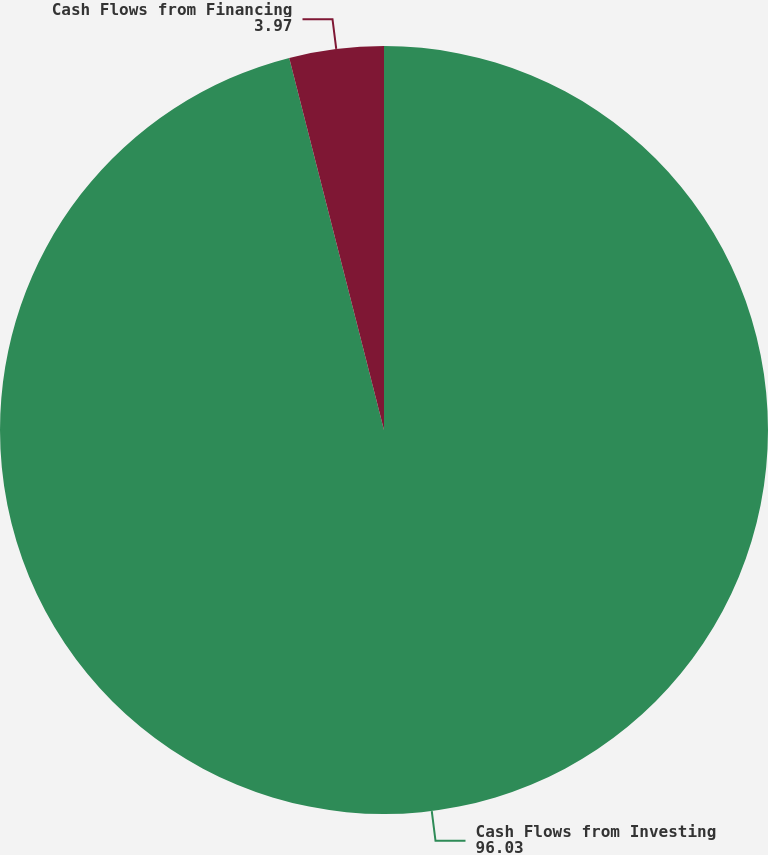<chart> <loc_0><loc_0><loc_500><loc_500><pie_chart><fcel>Cash Flows from Investing<fcel>Cash Flows from Financing<nl><fcel>96.03%<fcel>3.97%<nl></chart> 